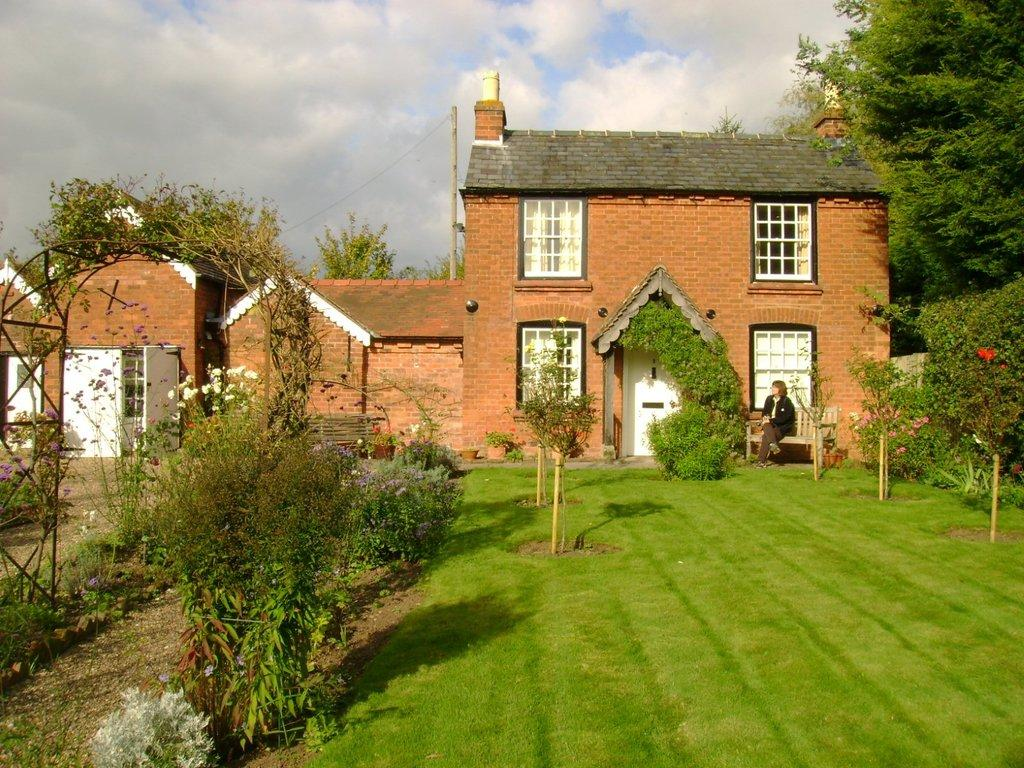What is the main structure in the image? There is a big building in the image. What is located in front of the building? There is a bench in front of the building. Who is sitting on the bench? A lady is sitting on the bench. What type of vegetation is present in the image? There is grass, plants, and trees in the image. What is visible in the sky? There are clouds in the sky. What type of plough is being used to cultivate the grass in the image? There is no plough present in the image; the grass is not being cultivated. What kind of bread is the lady eating on the bench? There is no bread visible in the image, and the lady is not eating anything. 